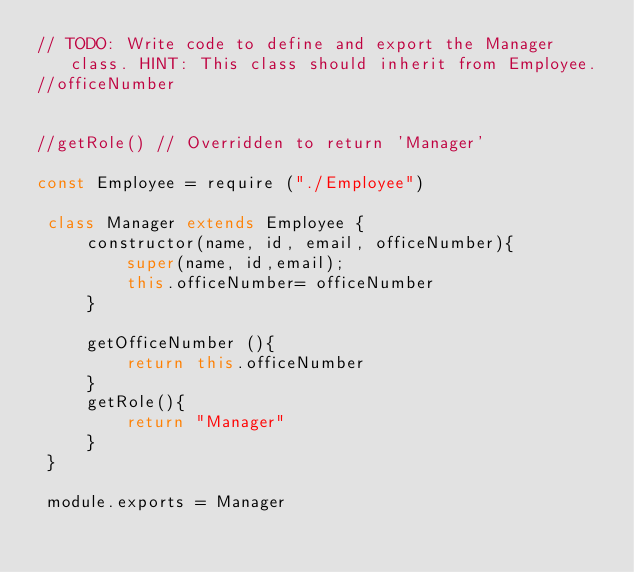<code> <loc_0><loc_0><loc_500><loc_500><_JavaScript_>// TODO: Write code to define and export the Manager class. HINT: This class should inherit from Employee.
//officeNumber


//getRole() // Overridden to return 'Manager'

const Employee = require ("./Employee")

 class Manager extends Employee {
     constructor(name, id, email, officeNumber){
         super(name, id,email);
         this.officeNumber= officeNumber
     }

     getOfficeNumber (){
         return this.officeNumber
     }
     getRole(){
         return "Manager"
     }
 }

 module.exports = Manager
</code> 